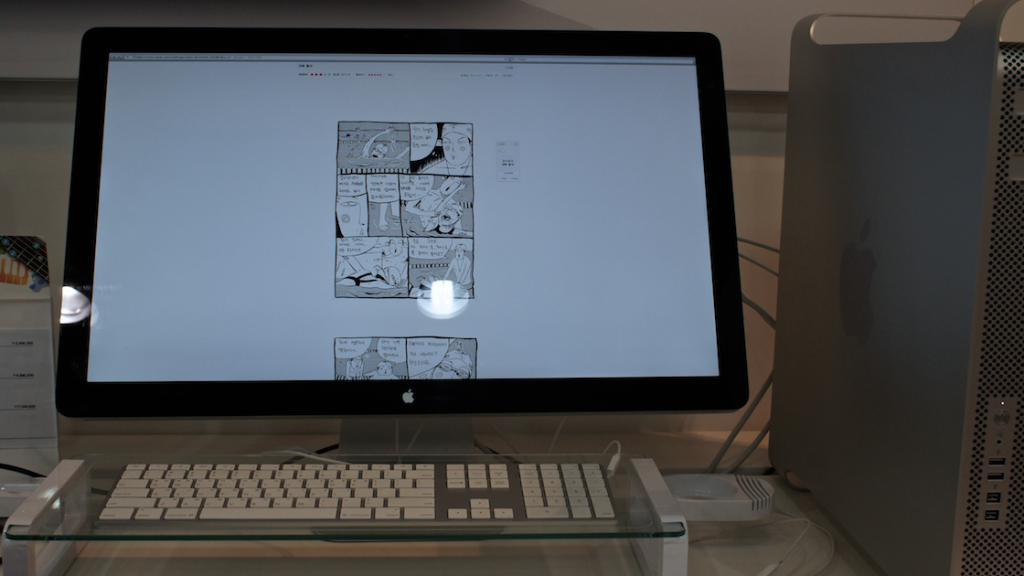What electronic device is the main subject of the image? There is a computer in the image. Where is the computer located in the image? The computer is placed on a desk in the image. How is the computer positioned in relation to the rest of the image? The computer is in the middle of the image. What can be seen on the computer's monitor? There is an image on the screen of the monitor. What type of song can be heard playing from the computer in the image? There is no indication of sound or music in the image, so it cannot be determined what type of song might be playing. 